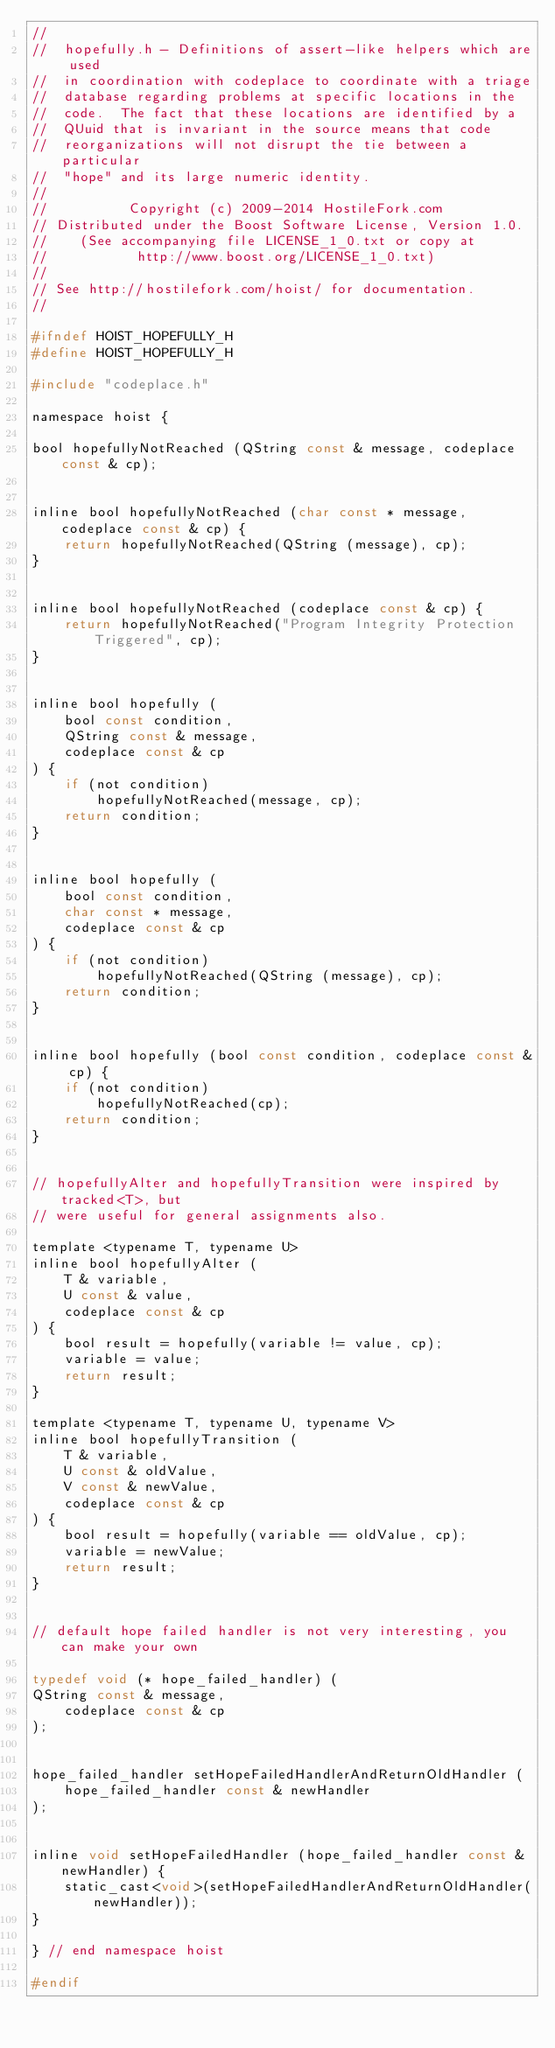Convert code to text. <code><loc_0><loc_0><loc_500><loc_500><_C_>//
//  hopefully.h - Definitions of assert-like helpers which are used
//  in coordination with codeplace to coordinate with a triage
//  database regarding problems at specific locations in the
//  code.  The fact that these locations are identified by a
//  QUuid that is invariant in the source means that code
//  reorganizations will not disrupt the tie between a particular
//  "hope" and its large numeric identity.
//
//          Copyright (c) 2009-2014 HostileFork.com
// Distributed under the Boost Software License, Version 1.0.
//    (See accompanying file LICENSE_1_0.txt or copy at
//           http://www.boost.org/LICENSE_1_0.txt)
//
// See http://hostilefork.com/hoist/ for documentation.
//

#ifndef HOIST_HOPEFULLY_H
#define HOIST_HOPEFULLY_H

#include "codeplace.h"

namespace hoist {

bool hopefullyNotReached (QString const & message, codeplace const & cp);


inline bool hopefullyNotReached (char const * message, codeplace const & cp) {
    return hopefullyNotReached(QString (message), cp);
}


inline bool hopefullyNotReached (codeplace const & cp) {
    return hopefullyNotReached("Program Integrity Protection Triggered", cp);
}


inline bool hopefully (
    bool const condition,
    QString const & message,
    codeplace const & cp
) {
    if (not condition)
        hopefullyNotReached(message, cp);
    return condition;
}


inline bool hopefully (
    bool const condition,
    char const * message,
    codeplace const & cp
) {
    if (not condition)
        hopefullyNotReached(QString (message), cp);
    return condition;
}


inline bool hopefully (bool const condition, codeplace const & cp) {
    if (not condition)
        hopefullyNotReached(cp);
    return condition;
}


// hopefullyAlter and hopefullyTransition were inspired by tracked<T>, but
// were useful for general assignments also.

template <typename T, typename U>
inline bool hopefullyAlter (
    T & variable,
    U const & value,
    codeplace const & cp
) {
    bool result = hopefully(variable != value, cp);
    variable = value;
    return result;
}

template <typename T, typename U, typename V>
inline bool hopefullyTransition (
    T & variable,
    U const & oldValue,
    V const & newValue,
    codeplace const & cp
) {
    bool result = hopefully(variable == oldValue, cp);
    variable = newValue;
    return result;
}


// default hope failed handler is not very interesting, you can make your own

typedef void (* hope_failed_handler) (
QString const & message,
    codeplace const & cp
); 


hope_failed_handler setHopeFailedHandlerAndReturnOldHandler (
    hope_failed_handler const & newHandler
);


inline void setHopeFailedHandler (hope_failed_handler const & newHandler) {
    static_cast<void>(setHopeFailedHandlerAndReturnOldHandler(newHandler));
}

} // end namespace hoist

#endif
</code> 